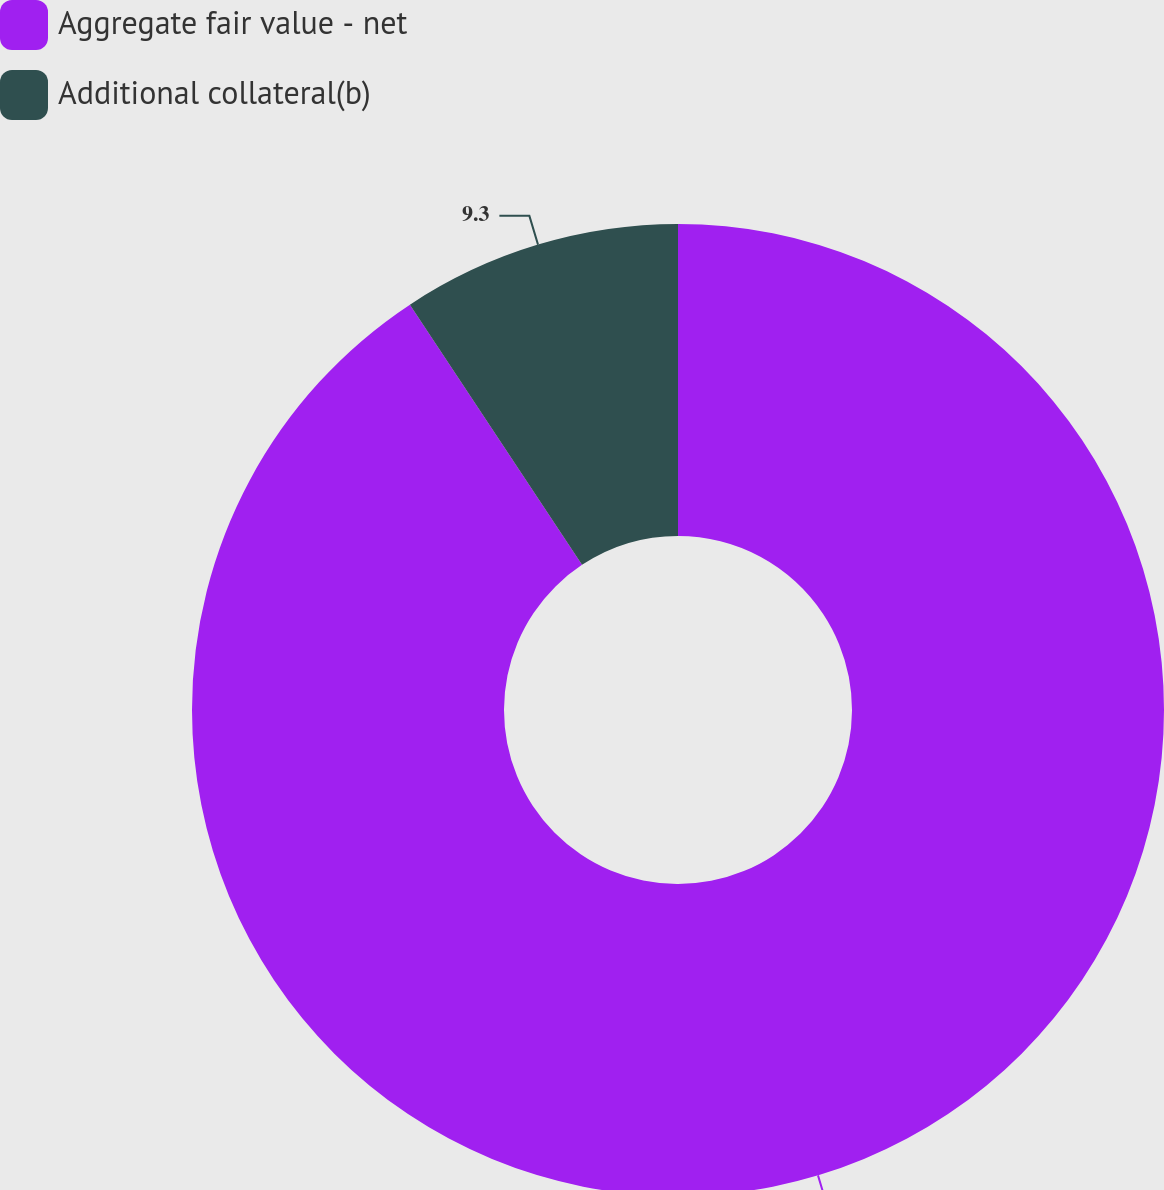Convert chart. <chart><loc_0><loc_0><loc_500><loc_500><pie_chart><fcel>Aggregate fair value - net<fcel>Additional collateral(b)<nl><fcel>90.7%<fcel>9.3%<nl></chart> 